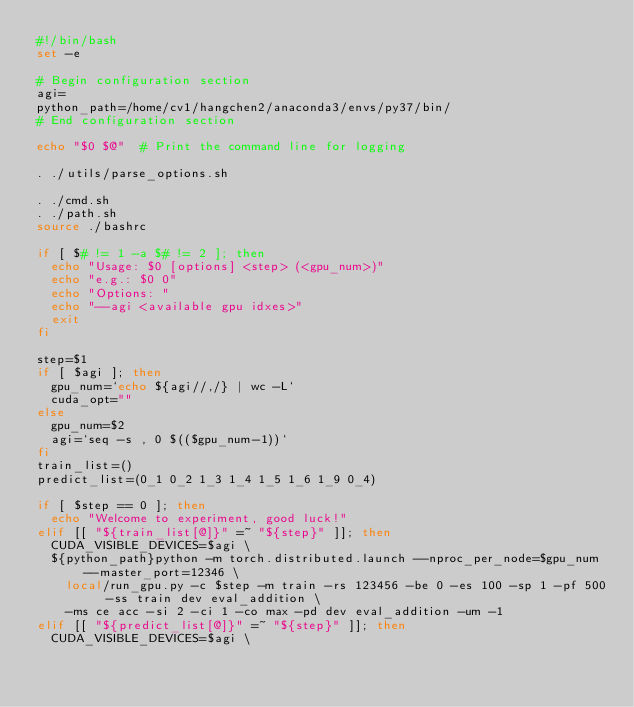Convert code to text. <code><loc_0><loc_0><loc_500><loc_500><_Bash_>#!/bin/bash
set -e

# Begin configuration section
agi=
python_path=/home/cv1/hangchen2/anaconda3/envs/py37/bin/
# End configuration section

echo "$0 $@"  # Print the command line for logging

. ./utils/parse_options.sh

. ./cmd.sh
. ./path.sh
source ./bashrc

if [ $# != 1 -a $# != 2 ]; then
  echo "Usage: $0 [options] <step> (<gpu_num>)"
  echo "e.g.: $0 0"
  echo "Options: "
  echo "--agi <available gpu idxes>"
  exit
fi

step=$1
if [ $agi ]; then
  gpu_num=`echo ${agi//,/} | wc -L`
  cuda_opt=""
else
  gpu_num=$2
  agi=`seq -s , 0 $(($gpu_num-1))`
fi
train_list=()
predict_list=(0_1 0_2 1_3 1_4 1_5 1_6 1_9 0_4)

if [ $step == 0 ]; then
  echo "Welcome to experiment, good luck!"
elif [[ "${train_list[@]}" =~ "${step}" ]]; then
  CUDA_VISIBLE_DEVICES=$agi \
  ${python_path}python -m torch.distributed.launch --nproc_per_node=$gpu_num --master_port=12346 \
    local/run_gpu.py -c $step -m train -rs 123456 -be 0 -es 100 -sp 1 -pf 500 -ss train dev eval_addition \
    -ms ce acc -si 2 -ci 1 -co max -pd dev eval_addition -um -1
elif [[ "${predict_list[@]}" =~ "${step}" ]]; then
  CUDA_VISIBLE_DEVICES=$agi \</code> 